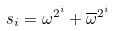<formula> <loc_0><loc_0><loc_500><loc_500>s _ { i } = \omega ^ { 2 ^ { i } } + \overline { \omega } ^ { 2 ^ { i } }</formula> 